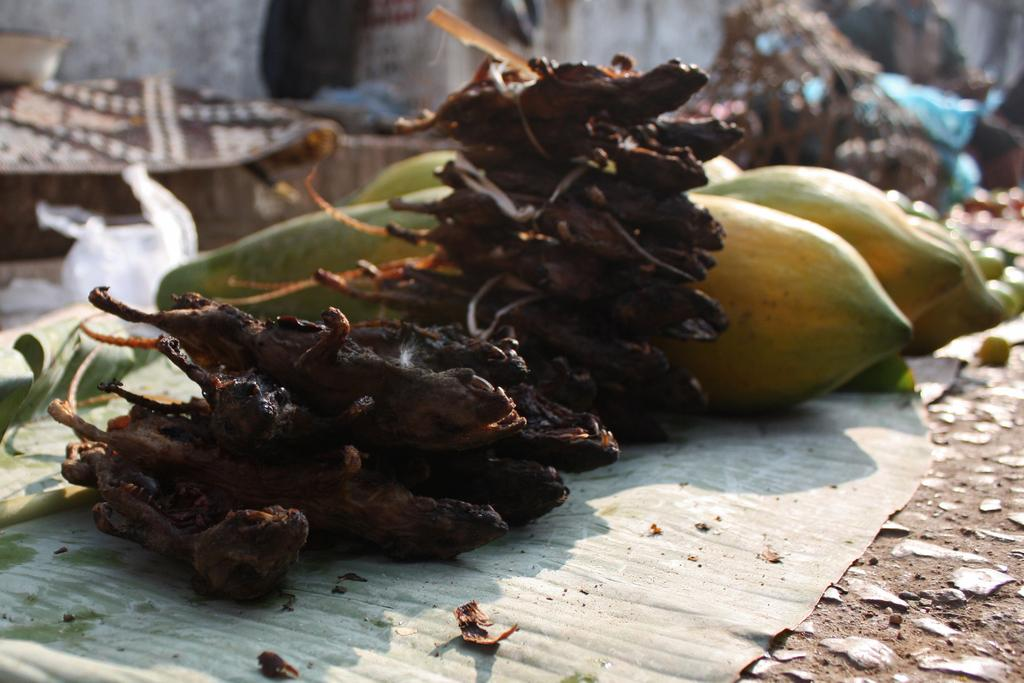What is the primary surface on which the food is placed in the image? The food is placed on a banana leaf in the image. What colors can be seen in the food? The food has yellow, green, and brown colors. Can you describe the background of the image? The background of the image is blurred. What letter is written on the toothpaste tube in the image? There is no toothpaste tube present in the image, so it is not possible to answer that question. 